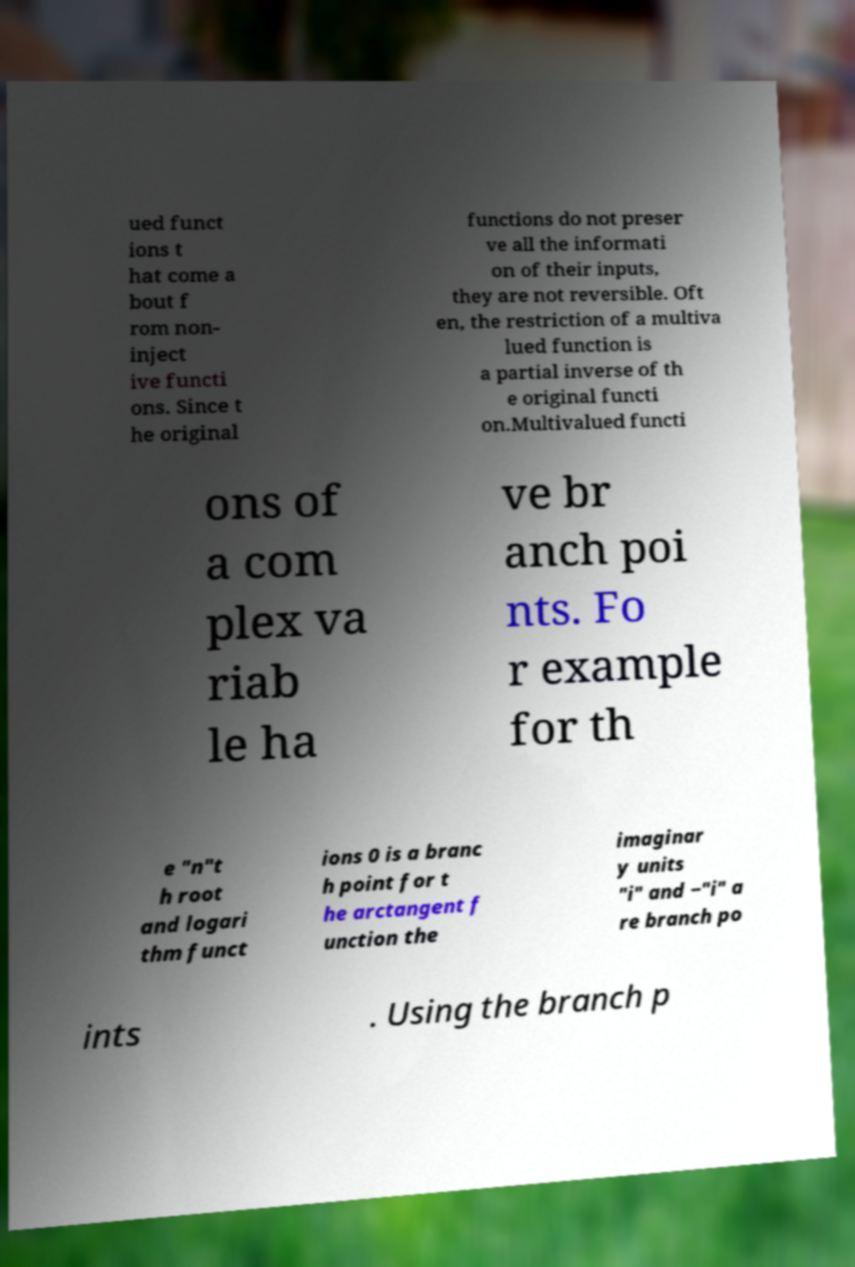Could you assist in decoding the text presented in this image and type it out clearly? ued funct ions t hat come a bout f rom non- inject ive functi ons. Since t he original functions do not preser ve all the informati on of their inputs, they are not reversible. Oft en, the restriction of a multiva lued function is a partial inverse of th e original functi on.Multivalued functi ons of a com plex va riab le ha ve br anch poi nts. Fo r example for th e "n"t h root and logari thm funct ions 0 is a branc h point for t he arctangent f unction the imaginar y units "i" and −"i" a re branch po ints . Using the branch p 